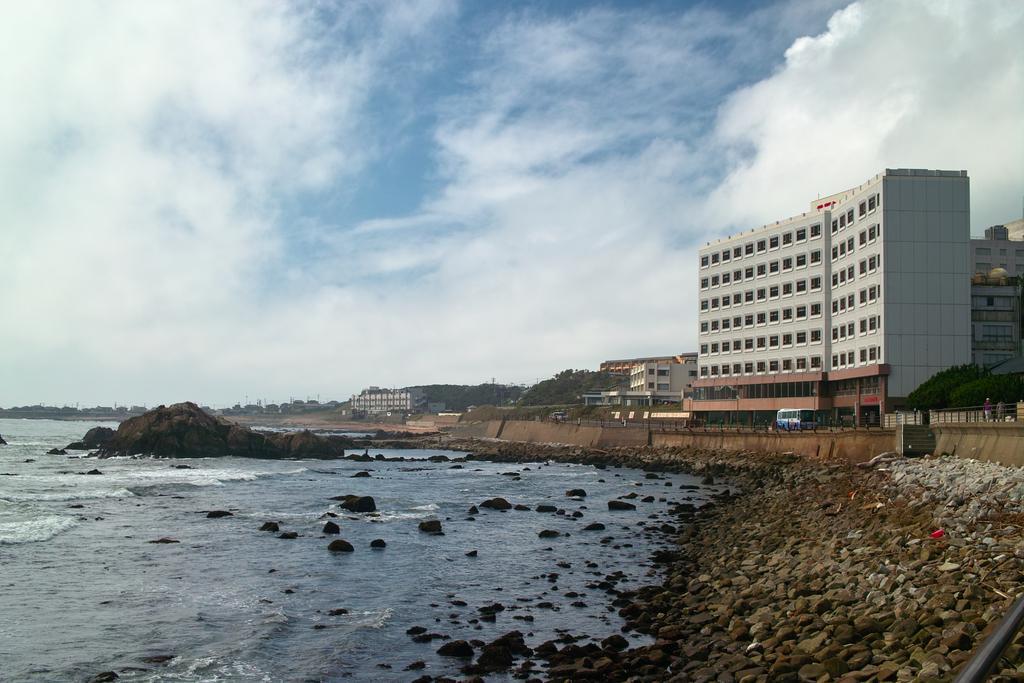Could you give a brief overview of what you see in this image? In this image we can see water. To the right side of the image we can see a building with windows, pillars, group of rocks, a vehicle parked on the road. In the background, we can see a group of buildings, trees and the cloudy sky. 